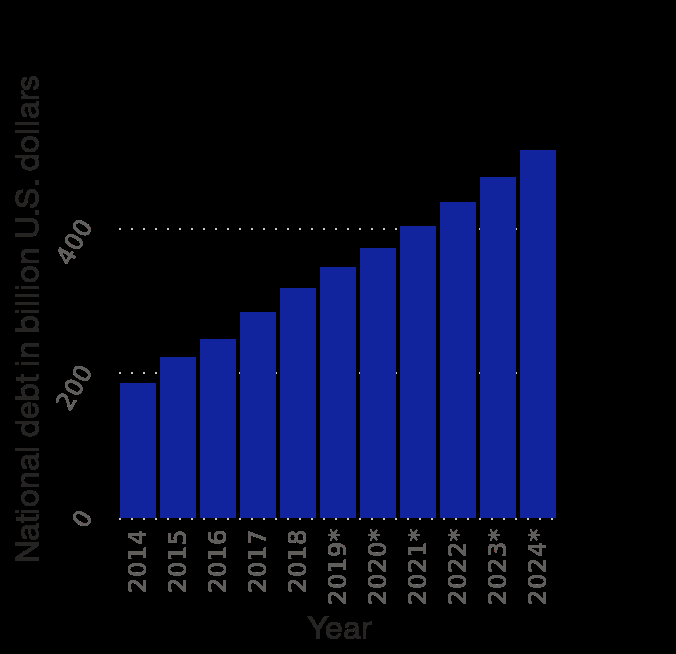<image>
Will the Indonesian national debt reach a plateau in the near future? No, the Indonesian national debt is projected to keep rising and not reach a plateau in the coming years. What has happened to Indonesian national debt since 2014?  Indonesian national debt has increased steadily since 2014. What does the y-axis represent in the bar graph?  The y-axis represents the national debt in billion U.S. dollars. What is the general trend of national debt from 2014 to 2024? The general trend of national debt from 2014 to 2024 cannot be determined without specific data points. please describe the details of the chart Indonesia : National debt from 2014 to 2024 (in billion U.S. dollars) is a bar graph. The x-axis shows Year while the y-axis plots National debt in billion U.S. dollars. Has the Indonesian national debt remained stable since 2014?  No, the Indonesian national debt has been steadily increasing since 2014. Is the sentence "Indonesia: National debt from 2014 to 2024 (in trillion U.S. dollars) is a pie chart" an interrogative sentence? No.Indonesia : National debt from 2014 to 2024 (in billion U.S. dollars) is a bar graph. The x-axis shows Year while the y-axis plots National debt in billion U.S. dollars. Does the y-axis represent the national debt in trillion U.S. dollars? No. The y-axis represents the national debt in billion U.S. dollars. 